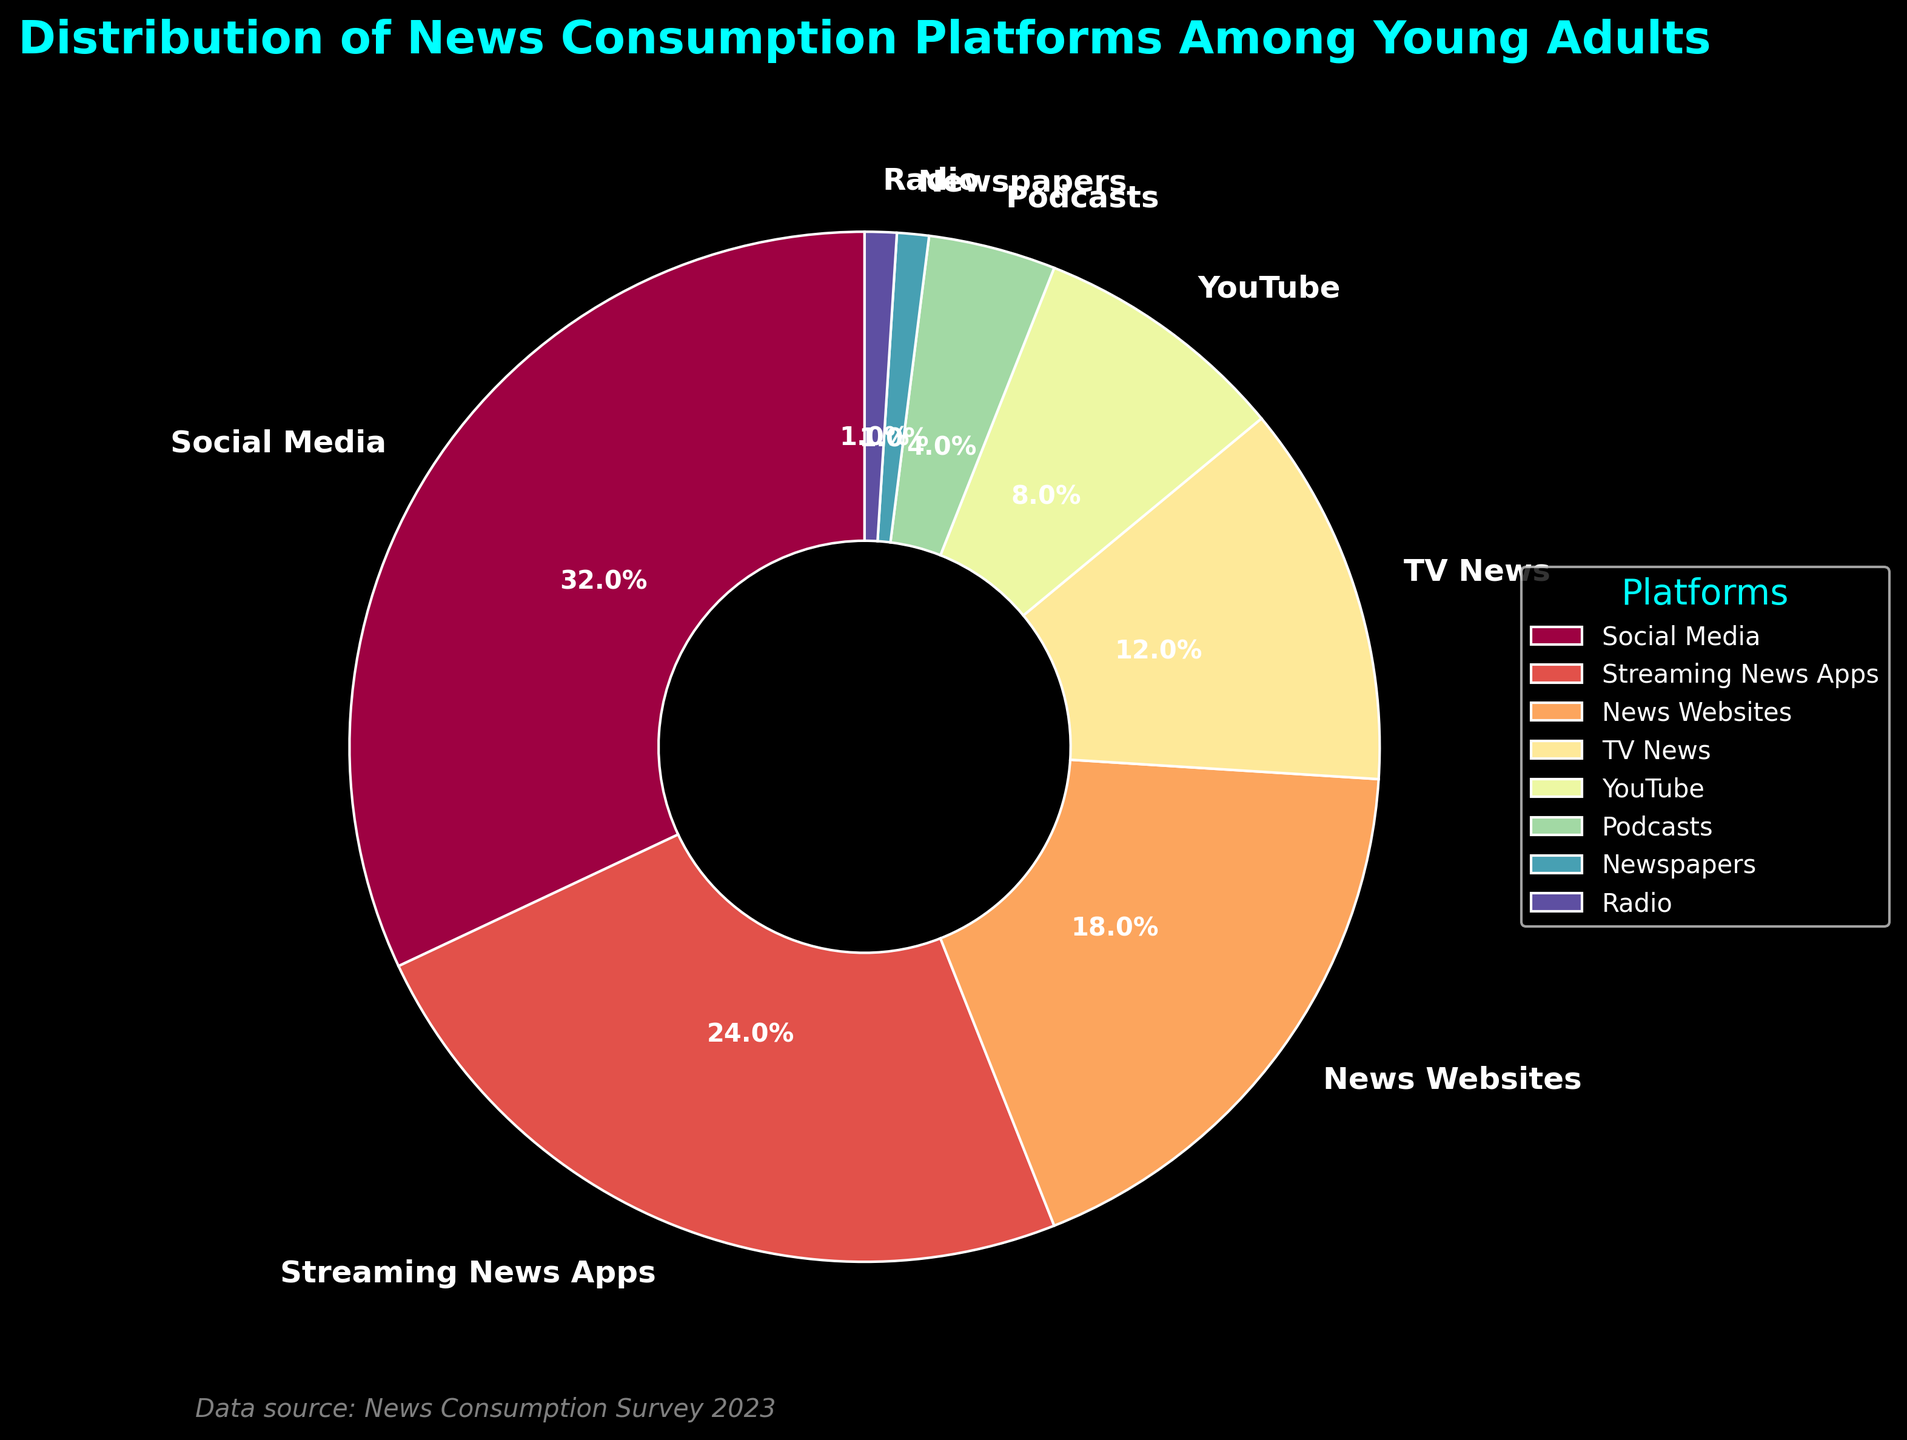What percentage of young adults consume news through Social Media? The wedge labeled 'Social Media' shows a percentage. Referring to this label will give the precise value.
Answer: 32% What is the combined percentage of young adults consuming news through News Websites and YouTube? Add the percentages for News Websites (18%) and YouTube (8%). 18 + 8 = 26
Answer: 26% Which platform has the lowest percentage of news consumption among young adults? The smallest wedge in the pie chart represents the platform with the lowest percentage. Both Newspapers and Radio have equal shares but the lowest compared to others.
Answer: Newspapers and Radio Is the percentage of young adults using Streaming News Apps greater than those using TV News? Compare the wedges labeled 'Streaming News Apps' and 'TV News'. Streaming News Apps is at 24%, while TV News is at 12%, thus 24 is greater than 12.
Answer: Yes What is the difference in news consumption percentages between Social Media and News Websites? Subtract the percentage of News Websites from Social Media. 32 - 18 = 14
Answer: 14 How many platforms have a news consumption percentage greater than 10%? Count the wedges with percentages over 10%. These platforms are Social Media (32%), Streaming News Apps (24%), News Websites (18%), and TV News (12%).
Answer: 4 What is the median value of the news consumption percentages listed in the figure? List the percentages in ascending order: 1, 1, 4, 8, 12, 18, 24, 32. The median is the average of the 4th and 5th values. (8 + 12) / 2 = 10
Answer: 10 Which platforms have visually prominent colors in the pie chart? Identify the wedges with distinctive or bright colors based on the provided colormap (Spectral). Typically, Social Media, Streaming News Apps, and News Websites employ visually striking colors in pie charts.
Answer: Social Media, Streaming News Apps, News Websites How many platforms have a consumption percentage below 5%? Count the wedges representing percentages under 5%. These platforms are Podcasts (4%), Newspapers (1%), and Radio (1%).
Answer: 3 